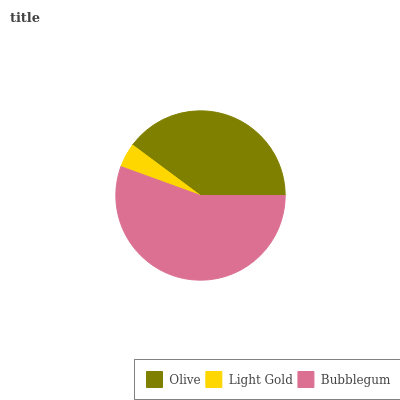Is Light Gold the minimum?
Answer yes or no. Yes. Is Bubblegum the maximum?
Answer yes or no. Yes. Is Bubblegum the minimum?
Answer yes or no. No. Is Light Gold the maximum?
Answer yes or no. No. Is Bubblegum greater than Light Gold?
Answer yes or no. Yes. Is Light Gold less than Bubblegum?
Answer yes or no. Yes. Is Light Gold greater than Bubblegum?
Answer yes or no. No. Is Bubblegum less than Light Gold?
Answer yes or no. No. Is Olive the high median?
Answer yes or no. Yes. Is Olive the low median?
Answer yes or no. Yes. Is Bubblegum the high median?
Answer yes or no. No. Is Light Gold the low median?
Answer yes or no. No. 